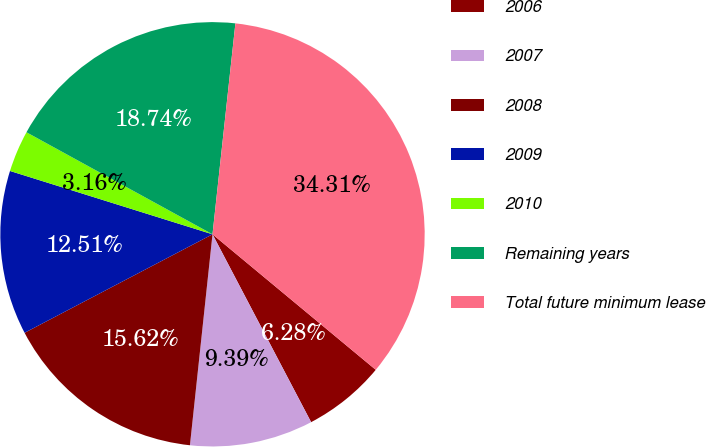Convert chart to OTSL. <chart><loc_0><loc_0><loc_500><loc_500><pie_chart><fcel>2006<fcel>2007<fcel>2008<fcel>2009<fcel>2010<fcel>Remaining years<fcel>Total future minimum lease<nl><fcel>6.28%<fcel>9.39%<fcel>15.62%<fcel>12.51%<fcel>3.16%<fcel>18.74%<fcel>34.31%<nl></chart> 